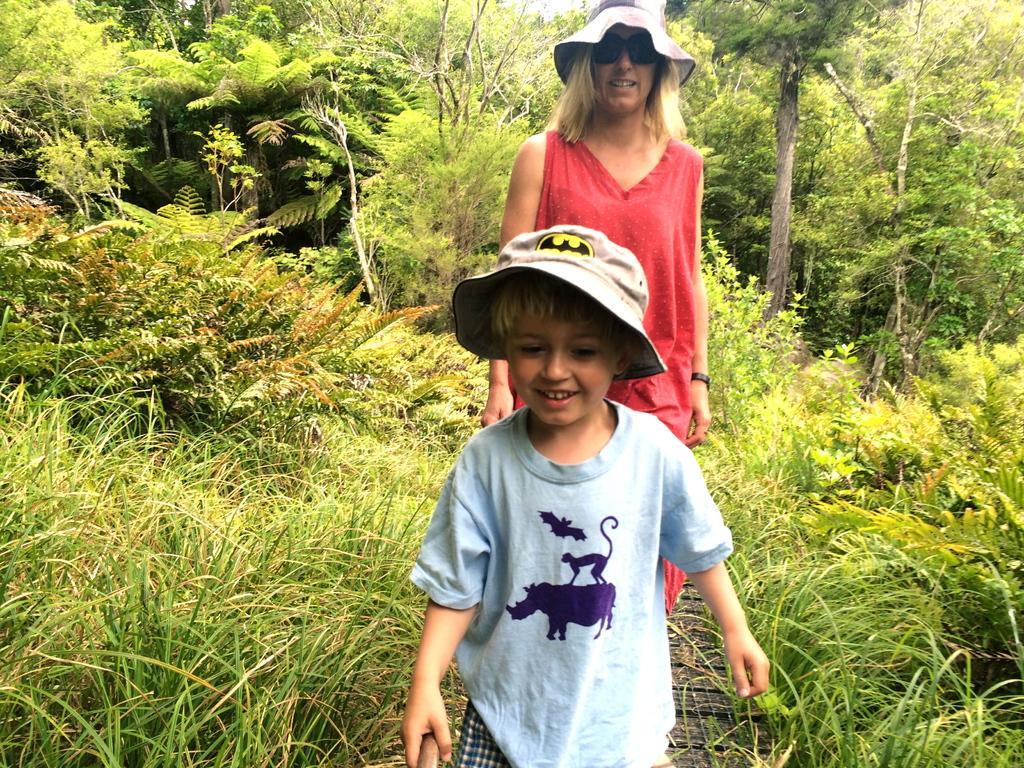Can you describe this image briefly? In the image there is a boy and behind the boy there is a woman, both of them are wearing hats and around them there is a lot of greenery. 